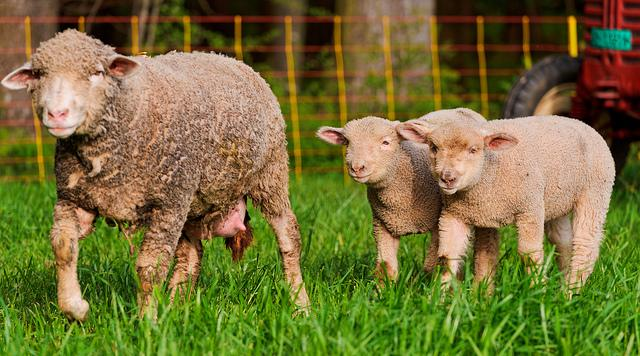How many lambs are lead by this sheep? two 